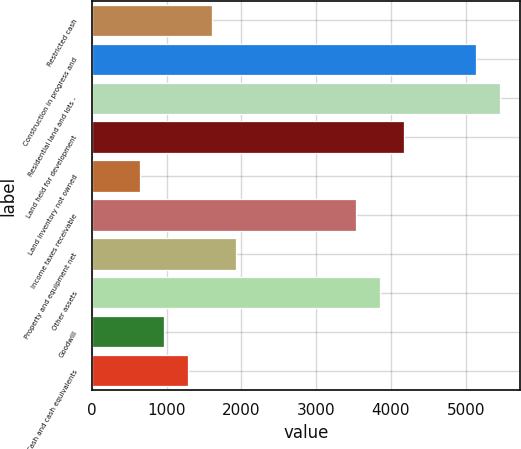Convert chart. <chart><loc_0><loc_0><loc_500><loc_500><bar_chart><fcel>Restricted cash<fcel>Construction in progress and<fcel>Residential land and lots -<fcel>Land held for development<fcel>Land inventory not owned<fcel>Income taxes receivable<fcel>Property and equipment net<fcel>Other assets<fcel>Goodwill<fcel>Cash and cash equivalents<nl><fcel>1605.9<fcel>5131.84<fcel>5452.38<fcel>4170.22<fcel>644.28<fcel>3529.14<fcel>1926.44<fcel>3849.68<fcel>964.82<fcel>1285.36<nl></chart> 